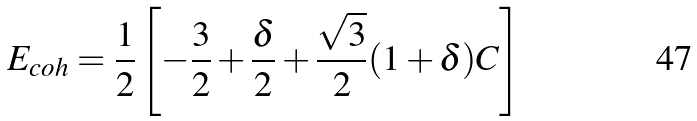<formula> <loc_0><loc_0><loc_500><loc_500>E _ { c o h } = \frac { 1 } { 2 } \left [ - \frac { 3 } { 2 } + \frac { \delta } { 2 } + \frac { \sqrt { 3 } } { 2 } ( 1 + \delta ) C \right ]</formula> 